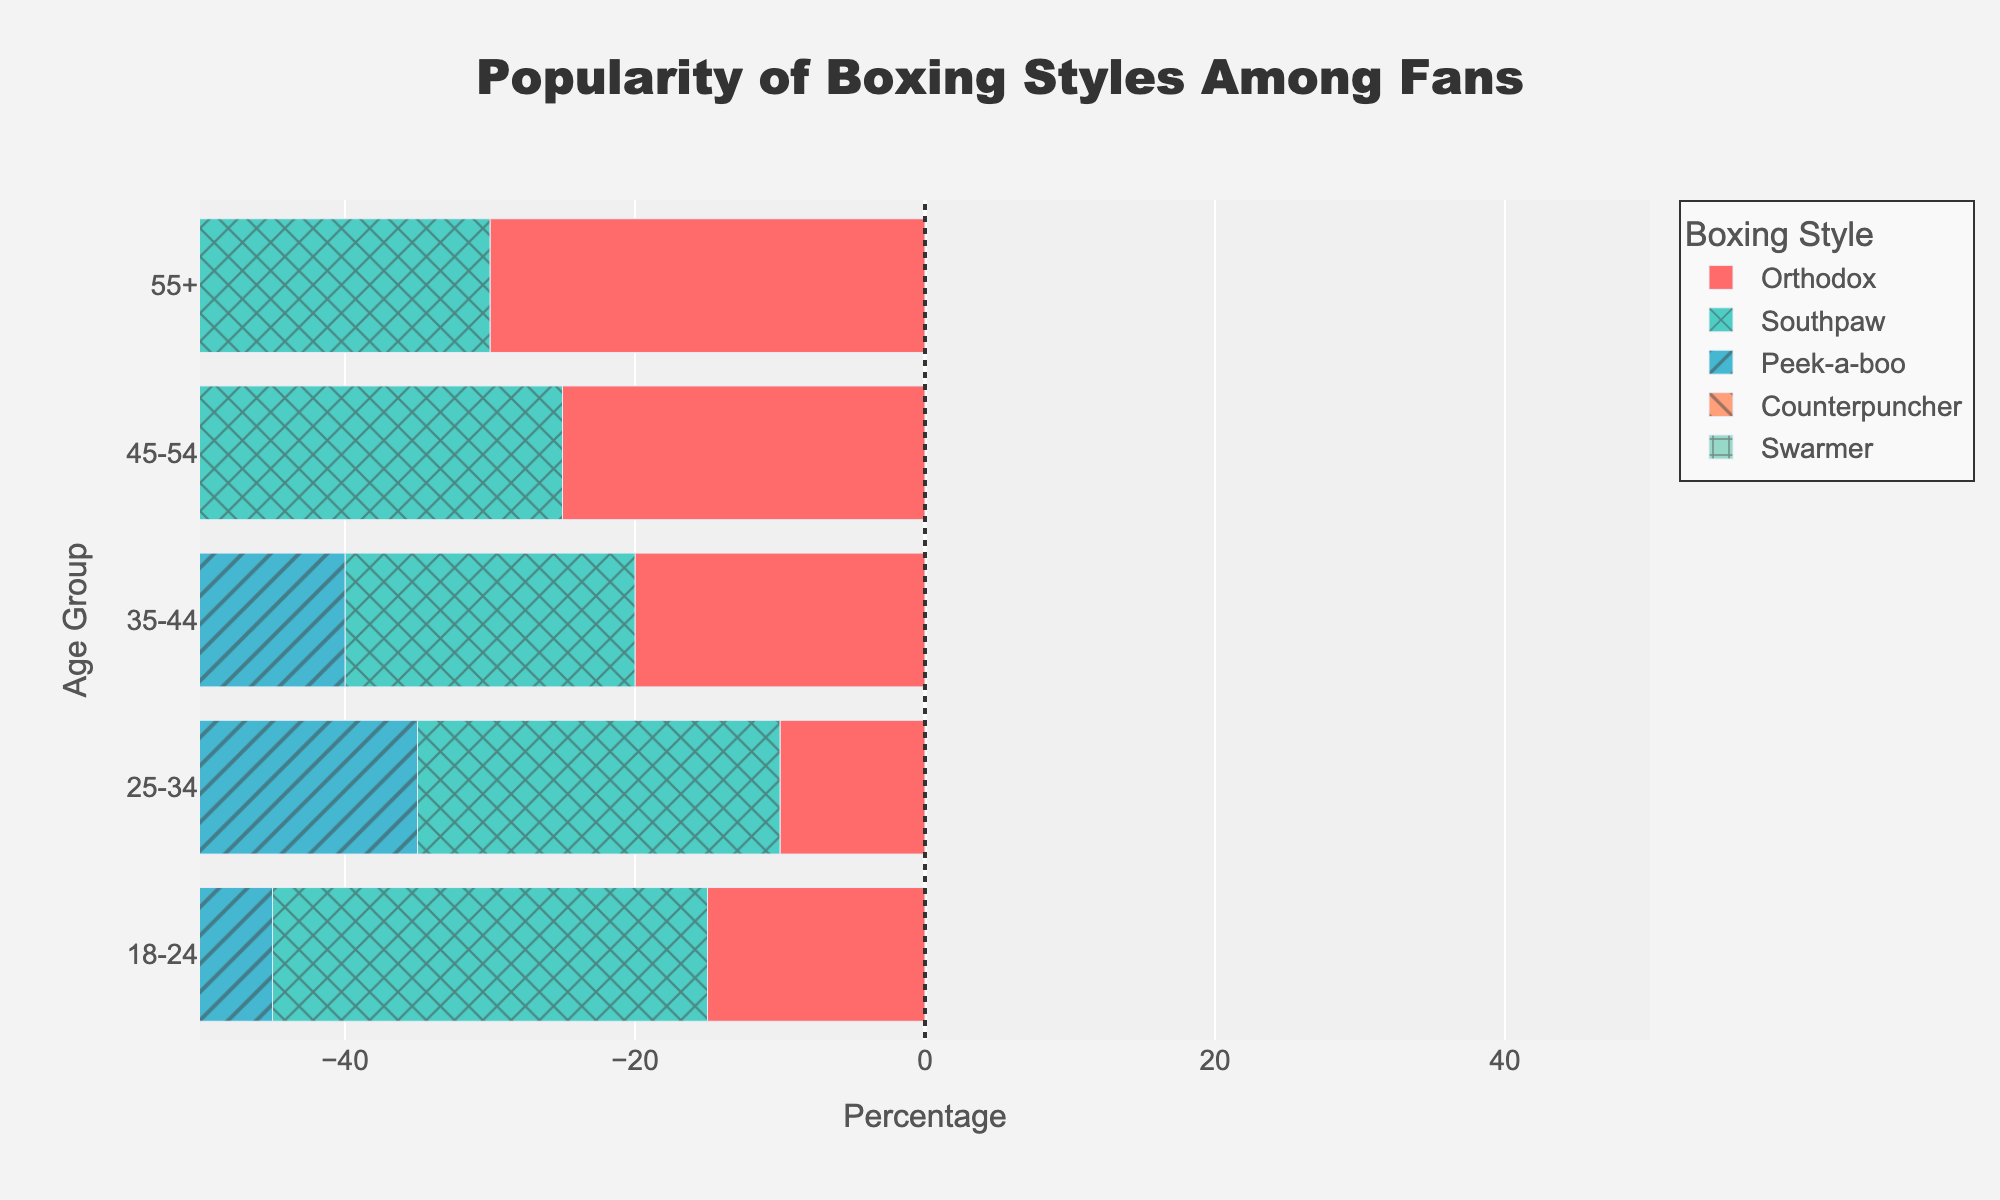Which age group has the highest percentage of fans for the Peek-a-boo style? To find the answer, look at the Peek-a-boo bars on the chart and find the longest bar. The longest bar corresponds to the 55+ age group, indicating that this group has the highest percentage of fans for the Peek-a-boo style.
Answer: 55+ Which boxing style is equally popular among the 25-34 age group? Look at the lengths of the bars for the 25-34 age group. The Orthodox and Southpaw bars are both of equal length, indicating that they have the same percentage of fans in this age group.
Answer: Orthodox and Southpaw Which style has the lowest percentage of fans in the 18-24 age group? Look at the bars for each style in the 18-24 age group. The bar for Counterpuncher is the shortest, indicating it has the lowest percentage of fans in this age group.
Answer: Counterpuncher How does the popularity of the Counterpuncher style among the 55+ age group compare to the Orthodox style in the same age group? Compare the lengths of the Counterpuncher and Orthodox bars for the 55+ age group. The Counterpuncher bar is longer, indicating it is more popular than the Orthodox style in the 55+ age group.
Answer: Counterpuncher is more popular What is the difference in popularity between the Orthodox and Southpaw styles in the 18-24 age group? Look at the bars for the Orthodox and Southpaw styles in the 18-24 age group. The Orthodox style has a percentage of 35%, while Southpaw has 20%. Thus, the difference in popularity is 35% - 20% = 15%.
Answer: 15% Which age group shows the least interest in the Swarmer style? Look at the lengths of the Swarmer bars across all age groups. The 45-54 and 55+ age groups both have the shortest bars, indicating they show the least interest in the Swarmer style.
Answer: 45-54 and 55+ In the 35-44 age group, which styles are preferred over Orthodox? Check the lengths of the bars for the 35-44 age group. The Orthodox bar is at 30%. Peek-a-boo (25%) and Counterpuncher (20%) are the styles with lower percentages, indicating that no styles are preferred over Orthodox.
Answer: None What is the combined percentage of fans for the Southpaw and Peek-a-boo styles in the 25-34 age group? Look at the 25-34 age group bars for Southpaw and Peek-a-boo. Southpaw has 25%, and Peek-a-boo has 20%. Adding these percentages, 25% + 20% = 45%.
Answer: 45% Which age group has the most varied preferences for different boxing styles? Look at the bars across each age group and assess the range of bar lengths for the different styles. The 55+ age group shows a significant range from 10% to 35%, indicating the most varied preferences.
Answer: 55+ What is the trend in the popularity of the Orthodox style as age increases? Observe the lengths of the Orthodox bars across the age groups. Starting from 18-24 (35%) and decreasing consistently across the age groups to 55+ (20%), there is a clear trend of decreasing popularity with increasing age.
Answer: Decreasing 